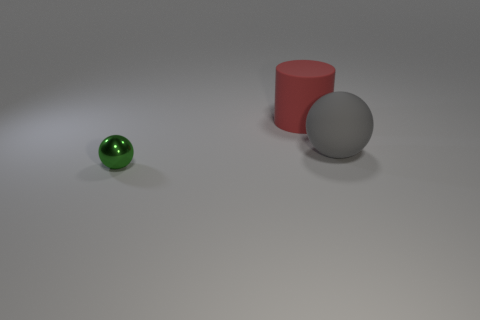What materials appear to be used for the objects in the image? The objects in the image seem to be made of different materials. The small green sphere has a reflective, possibly glass-like surface, the large middle object appears to be a matte finish sphere, and the red cylinder has a similar matte surface, suggesting a non-reflective paint or a plastic material. 